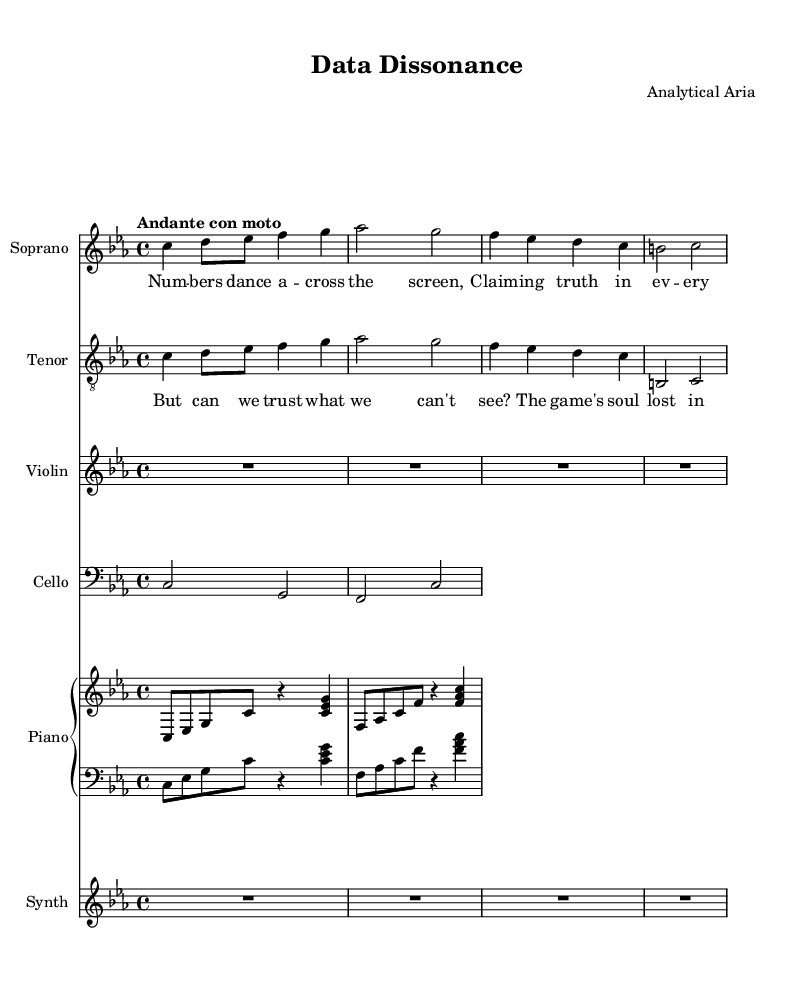What is the key signature of this music? The key signature is C minor, indicated by the presence of three flats (B flat, E flat, and A flat) in the key signature at the beginning of the staff.
Answer: C minor What is the time signature of this piece? The time signature is 4/4, shown at the beginning of the score. This indicates that there are four beats in each measure and the quarter note gets one beat.
Answer: 4/4 What is the tempo marking of this music? The tempo marking is "Andante con moto," which is a directive on how fast the piece should be played. "Andante" typically means a moderately slow tempo, "con moto" adds the instruction to play with motion or a bit faster.
Answer: Andante con moto How many voices are present in this score? There are four distinct voices: soprano, tenor, violin, and cello. Each voice is notated in its own staff, allowing for separate performance and interaction.
Answer: Four What thematic element is presented in the soprano's lyrics? The soprano lyrics discuss the concept of numbers and truth, indicating a theme related to data and perception. This reflects a central idea in the experimental opera regarding how data can represent reality.
Answer: Truth What contrasting viewpoint is highlighted in the tenor's lyrics? The tenor lyrics raise skepticism about the visibility of truth, questioning the reliability of data by emphasizing the potential loss of deeper understanding in binary representations.
Answer: Skepticism What instruments are used alongside the vocal parts? The score includes violin, cello, and piano, all of which contribute to the harmonic and melodic texture of the opera, creating a fuller sound alongside the vocal lines.
Answer: Violin, cello, piano 